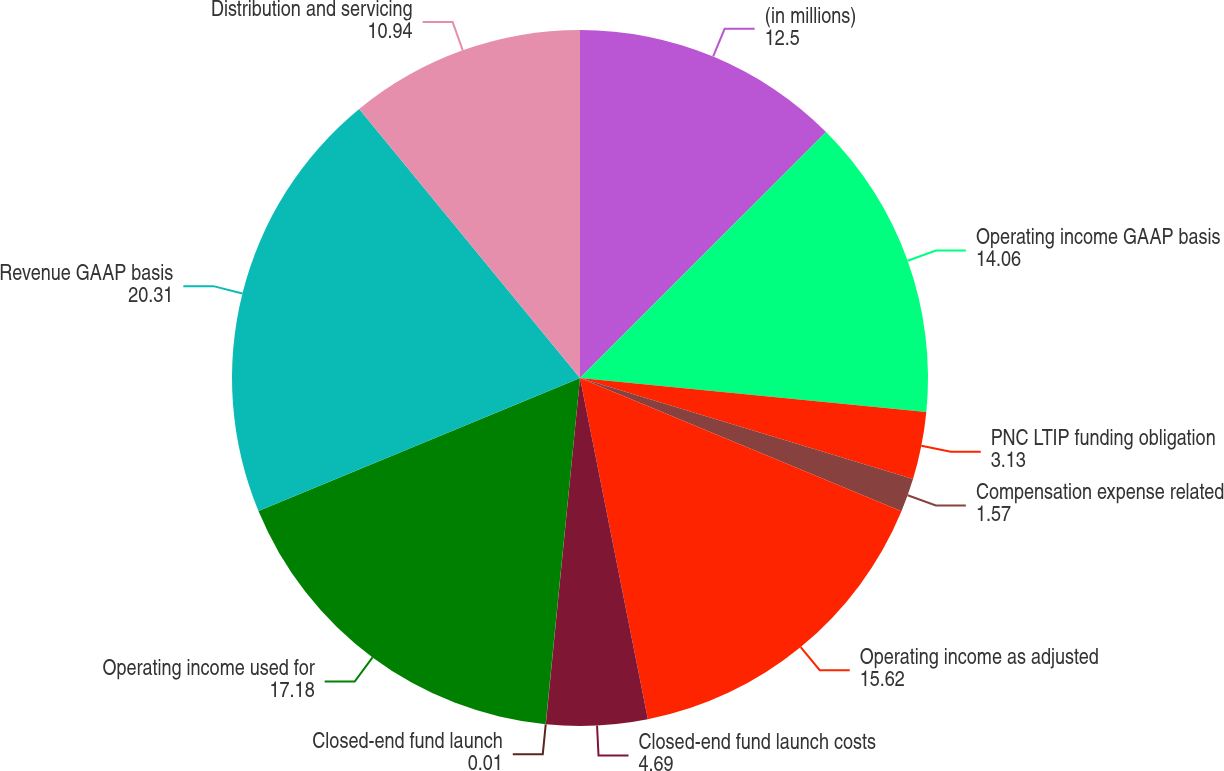<chart> <loc_0><loc_0><loc_500><loc_500><pie_chart><fcel>(in millions)<fcel>Operating income GAAP basis<fcel>PNC LTIP funding obligation<fcel>Compensation expense related<fcel>Operating income as adjusted<fcel>Closed-end fund launch costs<fcel>Closed-end fund launch<fcel>Operating income used for<fcel>Revenue GAAP basis<fcel>Distribution and servicing<nl><fcel>12.5%<fcel>14.06%<fcel>3.13%<fcel>1.57%<fcel>15.62%<fcel>4.69%<fcel>0.01%<fcel>17.18%<fcel>20.31%<fcel>10.94%<nl></chart> 